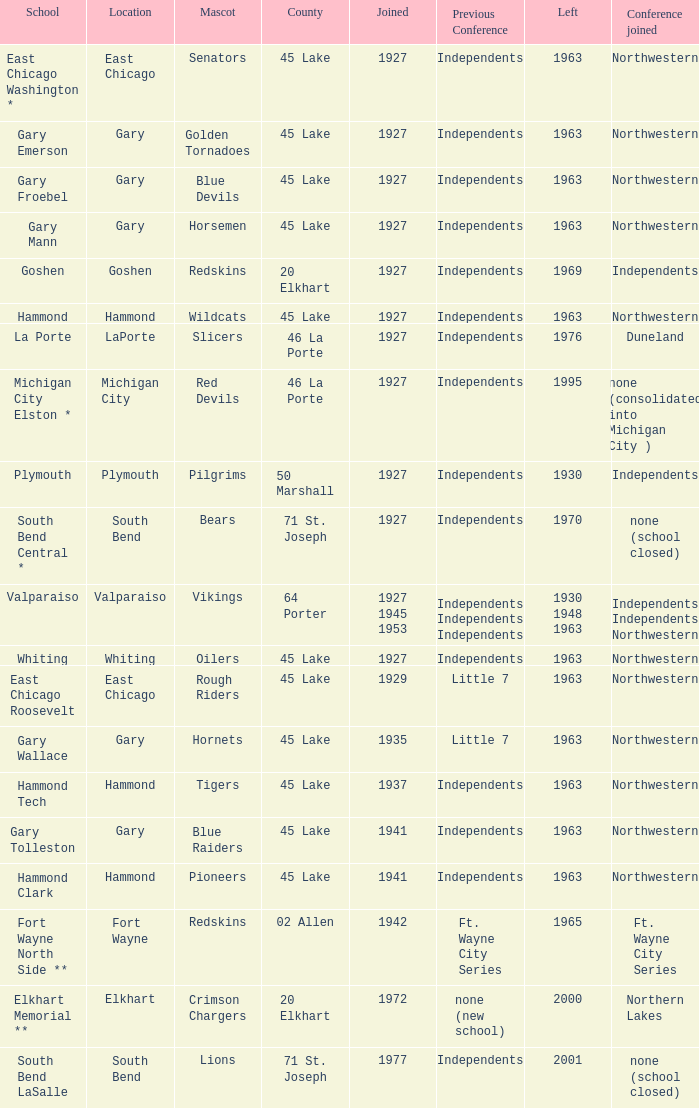When doeas Mascot of blue devils in Gary Froebel School? 1927.0. 